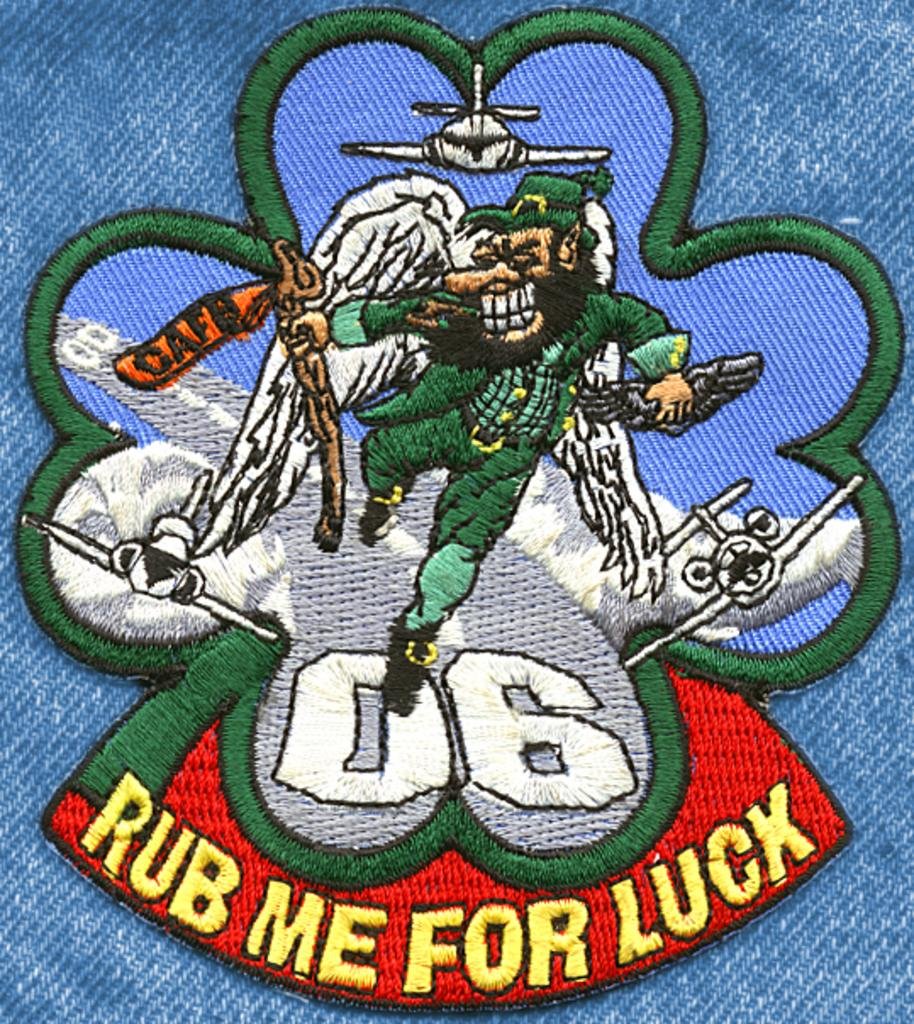What is the main subject of the image? The main subject of the image is an embroidery on a cloth. Can you describe the embroidery in the image? Unfortunately, the details of the embroidery cannot be determined from the image alone. What type of material is the cloth made of? The material of the cloth cannot be determined from the image alone. What type of oatmeal is being served in the image? There is no oatmeal present in the image; it features an embroidery on a cloth. Can you provide a list of the stories told by the embroidery in the image? There is no story present in the embroidery, as it is a visual art form and does not convey a narrative. 